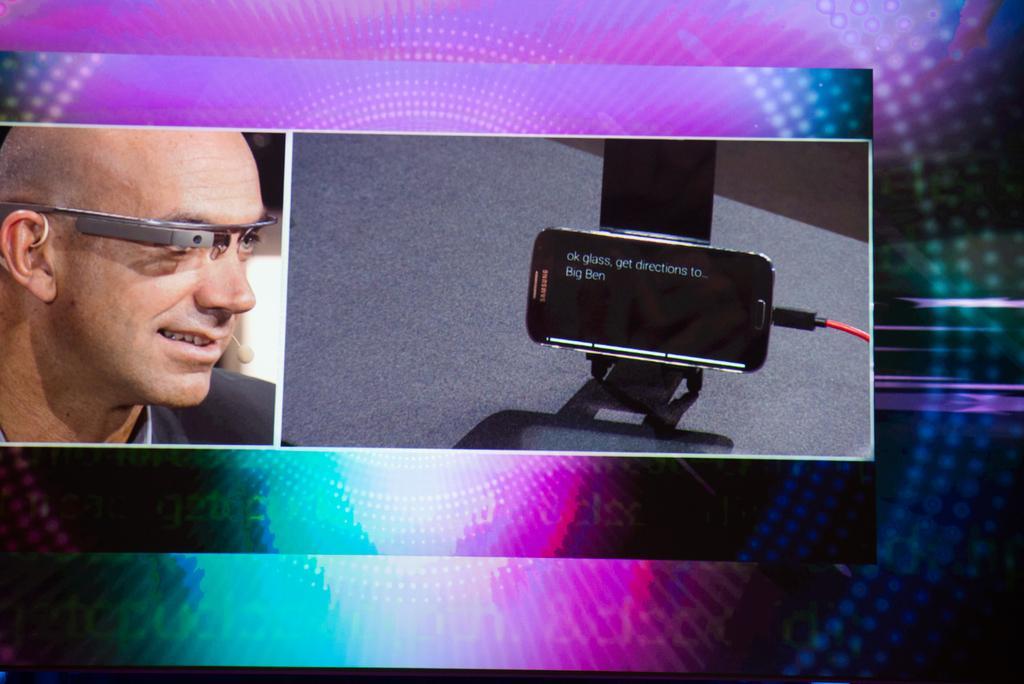How would you summarize this image in a sentence or two? This is an edited picture. In this image there is a man. On the right side of the image there is a phone and there is text on the screen. At the bottom it looks like a table. In the background there are multiple colors. 